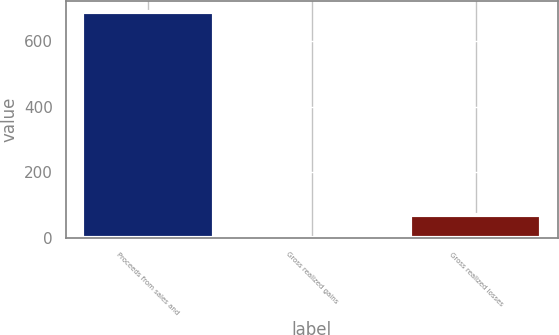<chart> <loc_0><loc_0><loc_500><loc_500><bar_chart><fcel>Proceeds from sales and<fcel>Gross realized gains<fcel>Gross realized losses<nl><fcel>689<fcel>0.9<fcel>69.71<nl></chart> 